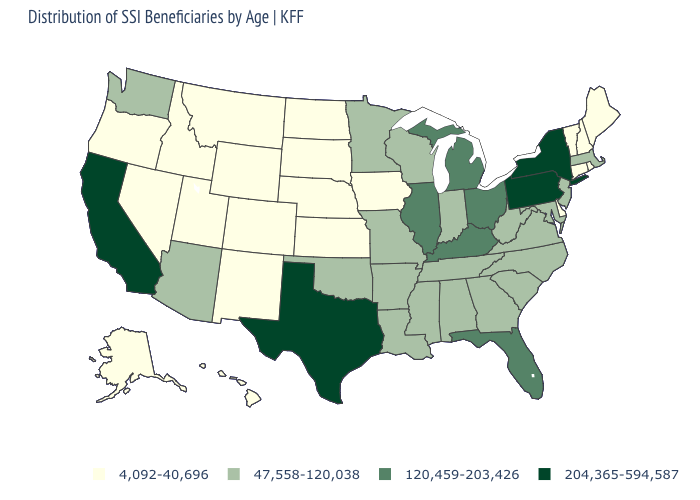Name the states that have a value in the range 204,365-594,587?
Answer briefly. California, New York, Pennsylvania, Texas. What is the value of Maryland?
Concise answer only. 47,558-120,038. Which states have the lowest value in the USA?
Be succinct. Alaska, Colorado, Connecticut, Delaware, Hawaii, Idaho, Iowa, Kansas, Maine, Montana, Nebraska, Nevada, New Hampshire, New Mexico, North Dakota, Oregon, Rhode Island, South Dakota, Utah, Vermont, Wyoming. Name the states that have a value in the range 47,558-120,038?
Answer briefly. Alabama, Arizona, Arkansas, Georgia, Indiana, Louisiana, Maryland, Massachusetts, Minnesota, Mississippi, Missouri, New Jersey, North Carolina, Oklahoma, South Carolina, Tennessee, Virginia, Washington, West Virginia, Wisconsin. Among the states that border North Dakota , which have the lowest value?
Write a very short answer. Montana, South Dakota. Is the legend a continuous bar?
Short answer required. No. What is the value of Maryland?
Answer briefly. 47,558-120,038. What is the value of Texas?
Give a very brief answer. 204,365-594,587. What is the value of Wyoming?
Quick response, please. 4,092-40,696. Does Mississippi have the lowest value in the South?
Give a very brief answer. No. Does Texas have the highest value in the South?
Short answer required. Yes. Name the states that have a value in the range 4,092-40,696?
Short answer required. Alaska, Colorado, Connecticut, Delaware, Hawaii, Idaho, Iowa, Kansas, Maine, Montana, Nebraska, Nevada, New Hampshire, New Mexico, North Dakota, Oregon, Rhode Island, South Dakota, Utah, Vermont, Wyoming. What is the highest value in the South ?
Answer briefly. 204,365-594,587. Which states have the highest value in the USA?
Concise answer only. California, New York, Pennsylvania, Texas. What is the lowest value in the West?
Short answer required. 4,092-40,696. 